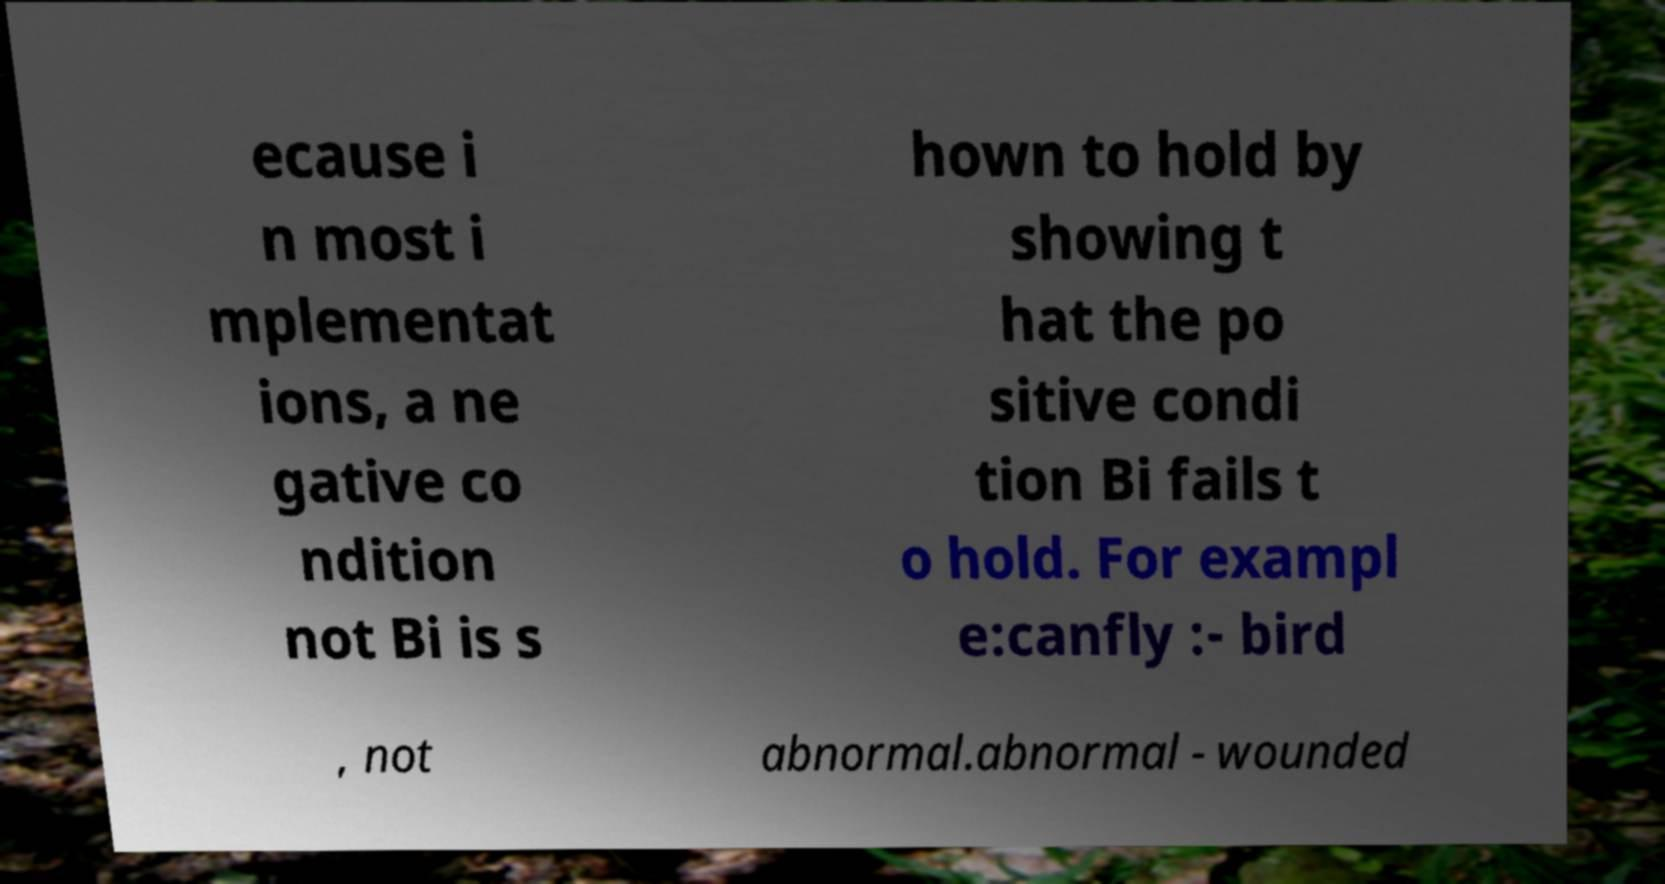Could you assist in decoding the text presented in this image and type it out clearly? ecause i n most i mplementat ions, a ne gative co ndition not Bi is s hown to hold by showing t hat the po sitive condi tion Bi fails t o hold. For exampl e:canfly :- bird , not abnormal.abnormal - wounded 